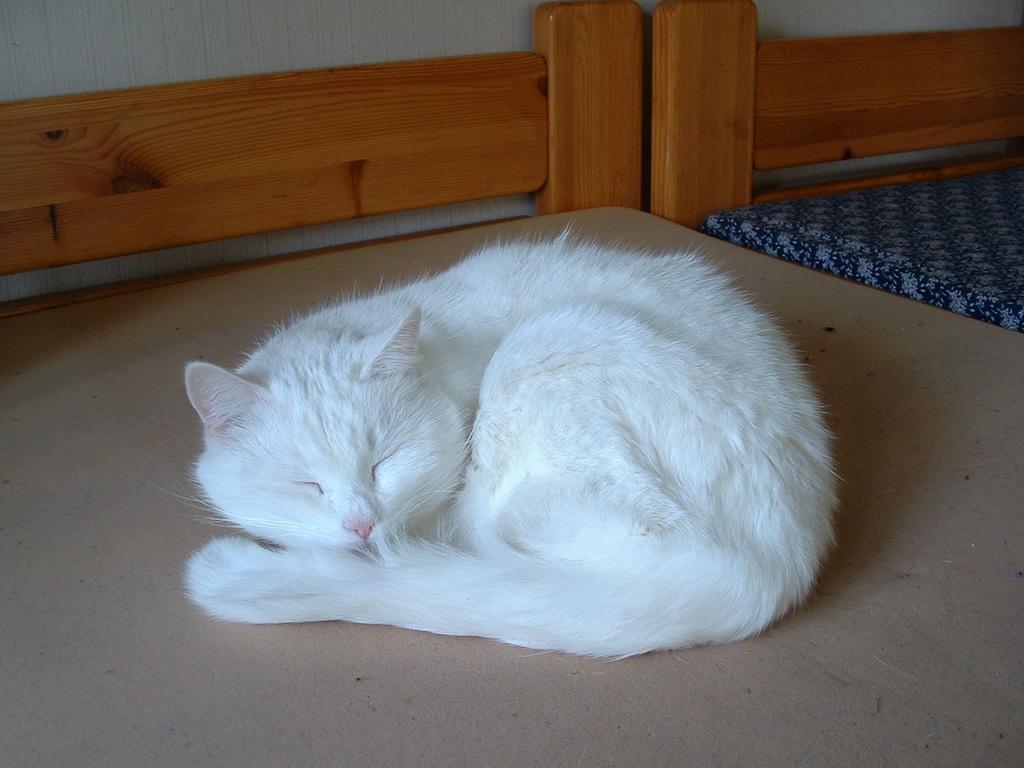Can you describe this image briefly? Here I can see a white color cat is laying on a bench which is made up of wood. Beside this I can see a bed. At the top I can see the wall. 